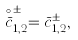<formula> <loc_0><loc_0><loc_500><loc_500>\stackrel { \circ } { \bar { c } } _ { 1 , 2 } ^ { \pm } = { \bar { c } } _ { 1 , 2 } ^ { \pm } ,</formula> 